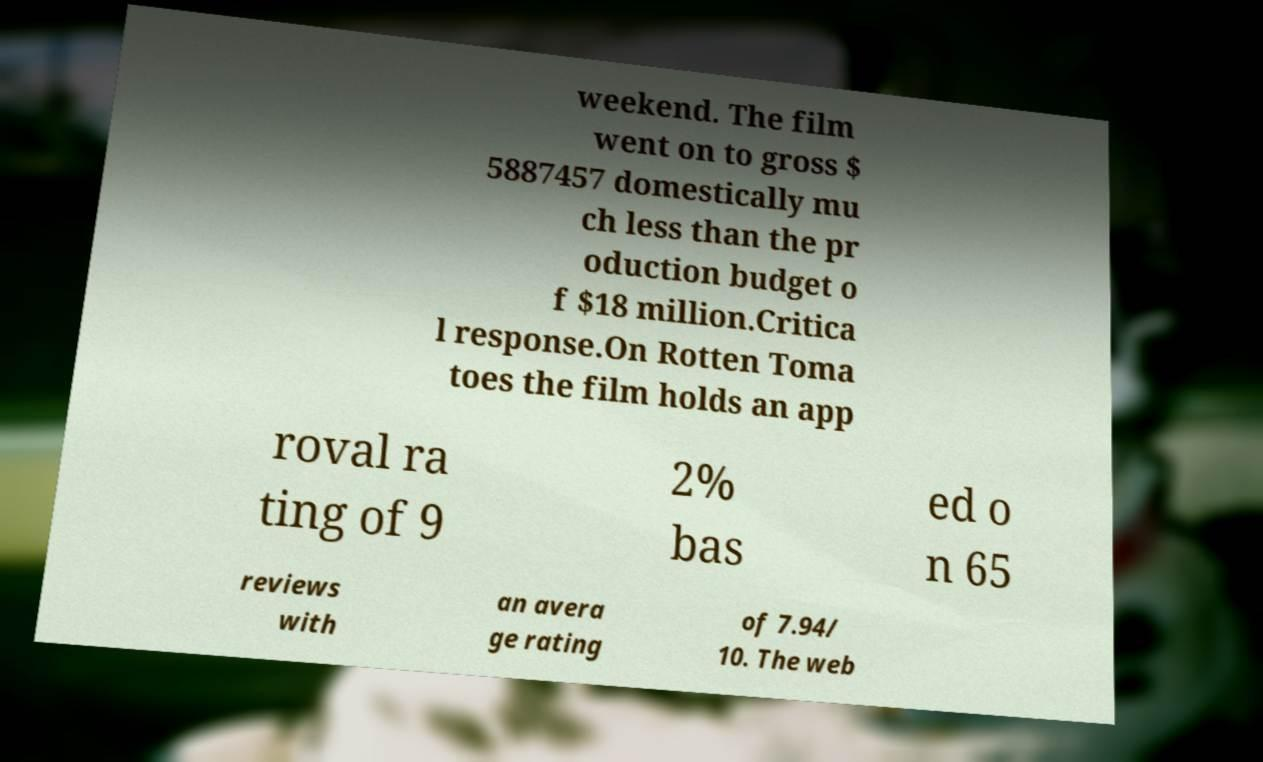What messages or text are displayed in this image? I need them in a readable, typed format. weekend. The film went on to gross $ 5887457 domestically mu ch less than the pr oduction budget o f $18 million.Critica l response.On Rotten Toma toes the film holds an app roval ra ting of 9 2% bas ed o n 65 reviews with an avera ge rating of 7.94/ 10. The web 